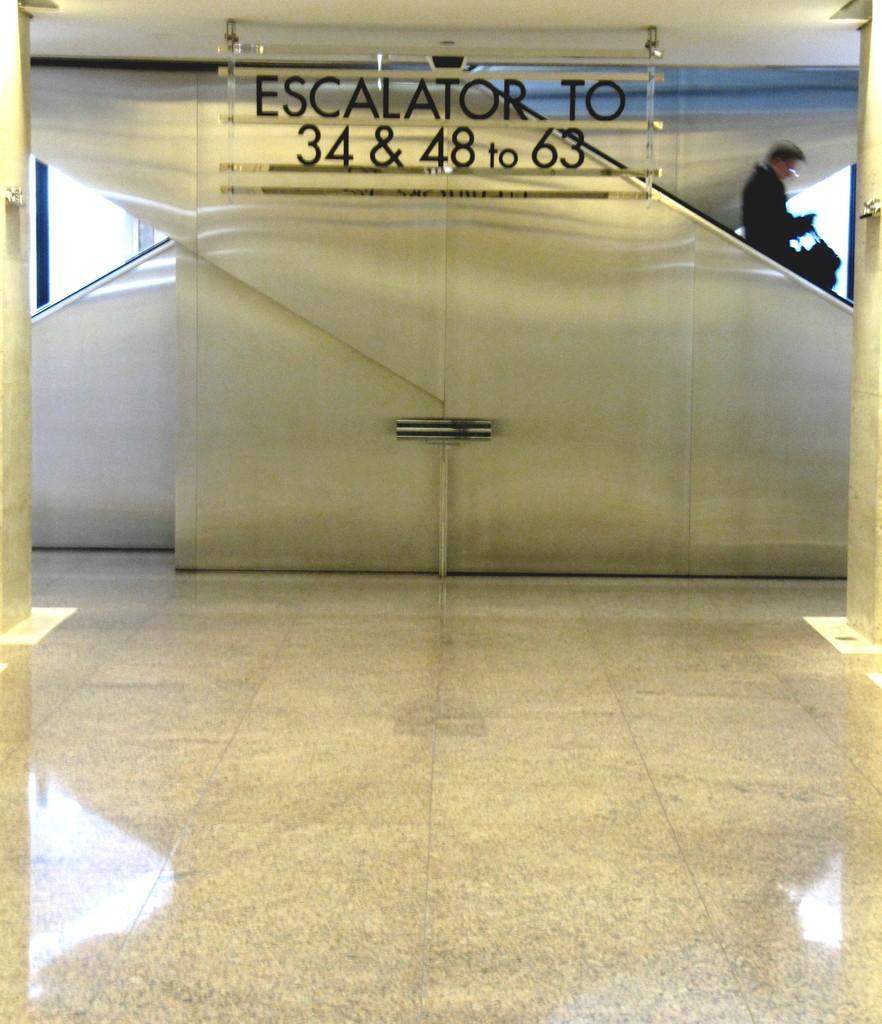Could you give a brief overview of what you see in this image? In this image I can see a staircase, text, lights and a person is holding a bag in hand. This image is taken may be in a building. 